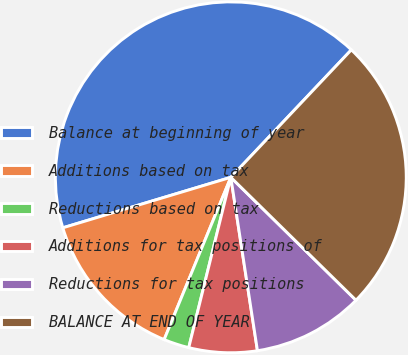Convert chart to OTSL. <chart><loc_0><loc_0><loc_500><loc_500><pie_chart><fcel>Balance at beginning of year<fcel>Additions based on tax<fcel>Reductions based on tax<fcel>Additions for tax positions of<fcel>Reductions for tax positions<fcel>BALANCE AT END OF YEAR<nl><fcel>41.7%<fcel>14.15%<fcel>2.35%<fcel>6.28%<fcel>10.22%<fcel>25.3%<nl></chart> 